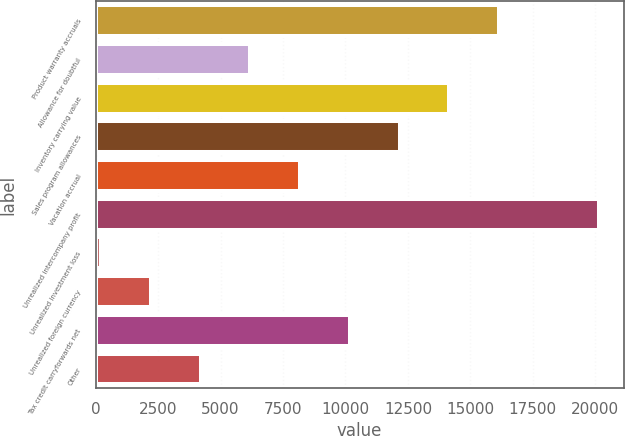Convert chart to OTSL. <chart><loc_0><loc_0><loc_500><loc_500><bar_chart><fcel>Product warranty accruals<fcel>Allowance for doubtful<fcel>Inventory carrying value<fcel>Sales program allowances<fcel>Vacation accrual<fcel>Unrealized intercompany profit<fcel>Unrealized investment loss<fcel>Unrealized foreign currency<fcel>Tax credit carryforwards net<fcel>Other<nl><fcel>16147<fcel>6192<fcel>14156<fcel>12165<fcel>8183<fcel>20129<fcel>219<fcel>2210<fcel>10174<fcel>4201<nl></chart> 